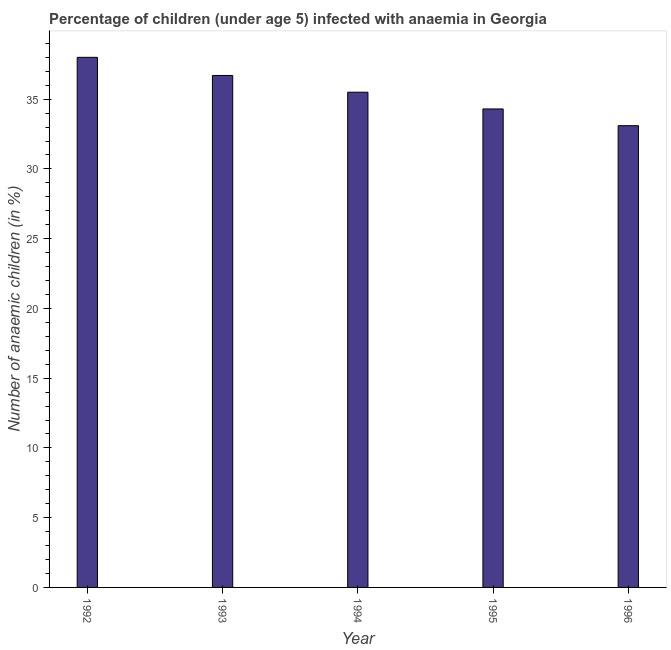Does the graph contain any zero values?
Your answer should be compact. No. What is the title of the graph?
Provide a succinct answer. Percentage of children (under age 5) infected with anaemia in Georgia. What is the label or title of the X-axis?
Keep it short and to the point. Year. What is the label or title of the Y-axis?
Make the answer very short. Number of anaemic children (in %). What is the number of anaemic children in 1995?
Offer a terse response. 34.3. Across all years, what is the minimum number of anaemic children?
Keep it short and to the point. 33.1. In which year was the number of anaemic children minimum?
Offer a very short reply. 1996. What is the sum of the number of anaemic children?
Ensure brevity in your answer.  177.6. What is the average number of anaemic children per year?
Make the answer very short. 35.52. What is the median number of anaemic children?
Provide a succinct answer. 35.5. What is the ratio of the number of anaemic children in 1993 to that in 1996?
Offer a very short reply. 1.11. What is the difference between the highest and the second highest number of anaemic children?
Offer a very short reply. 1.3. Is the sum of the number of anaemic children in 1992 and 1996 greater than the maximum number of anaemic children across all years?
Your response must be concise. Yes. In how many years, is the number of anaemic children greater than the average number of anaemic children taken over all years?
Offer a terse response. 2. Are all the bars in the graph horizontal?
Your answer should be compact. No. What is the difference between two consecutive major ticks on the Y-axis?
Offer a very short reply. 5. Are the values on the major ticks of Y-axis written in scientific E-notation?
Give a very brief answer. No. What is the Number of anaemic children (in %) of 1993?
Your answer should be very brief. 36.7. What is the Number of anaemic children (in %) in 1994?
Offer a very short reply. 35.5. What is the Number of anaemic children (in %) of 1995?
Ensure brevity in your answer.  34.3. What is the Number of anaemic children (in %) of 1996?
Give a very brief answer. 33.1. What is the difference between the Number of anaemic children (in %) in 1992 and 1994?
Offer a terse response. 2.5. What is the difference between the Number of anaemic children (in %) in 1992 and 1995?
Your answer should be compact. 3.7. What is the difference between the Number of anaemic children (in %) in 1993 and 1994?
Your answer should be compact. 1.2. What is the difference between the Number of anaemic children (in %) in 1994 and 1995?
Your answer should be very brief. 1.2. What is the difference between the Number of anaemic children (in %) in 1994 and 1996?
Offer a terse response. 2.4. What is the difference between the Number of anaemic children (in %) in 1995 and 1996?
Your answer should be compact. 1.2. What is the ratio of the Number of anaemic children (in %) in 1992 to that in 1993?
Your response must be concise. 1.03. What is the ratio of the Number of anaemic children (in %) in 1992 to that in 1994?
Offer a very short reply. 1.07. What is the ratio of the Number of anaemic children (in %) in 1992 to that in 1995?
Provide a short and direct response. 1.11. What is the ratio of the Number of anaemic children (in %) in 1992 to that in 1996?
Your response must be concise. 1.15. What is the ratio of the Number of anaemic children (in %) in 1993 to that in 1994?
Provide a succinct answer. 1.03. What is the ratio of the Number of anaemic children (in %) in 1993 to that in 1995?
Provide a short and direct response. 1.07. What is the ratio of the Number of anaemic children (in %) in 1993 to that in 1996?
Your answer should be very brief. 1.11. What is the ratio of the Number of anaemic children (in %) in 1994 to that in 1995?
Your response must be concise. 1.03. What is the ratio of the Number of anaemic children (in %) in 1994 to that in 1996?
Ensure brevity in your answer.  1.07. What is the ratio of the Number of anaemic children (in %) in 1995 to that in 1996?
Ensure brevity in your answer.  1.04. 